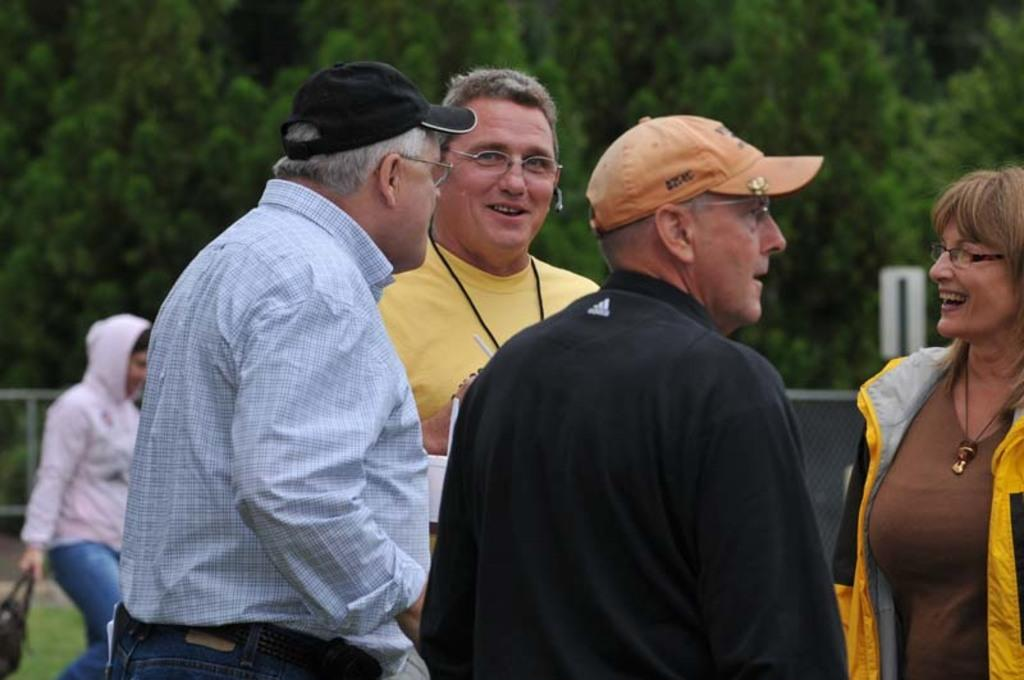How many people are in the image? There are people in the image, but the exact number is not specified. What is one of the people doing in the image? There is a person holding a bag and walking in the image. What can be seen in the background of the image? There are trees in the image, and the background is blurred. What is present in the image that might be used for enclosing or separating areas? There is fencing in the image. What type of noise can be heard coming from the library in the image? There is no library present in the image, so it is not possible to determine what, if any, noise might be heard. 